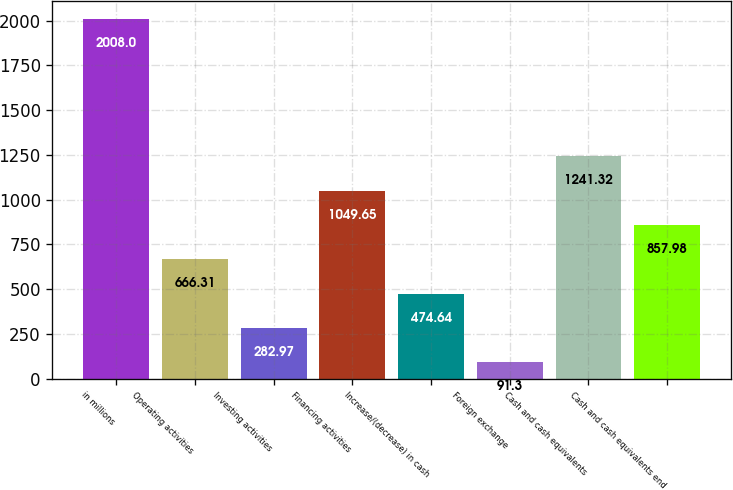Convert chart to OTSL. <chart><loc_0><loc_0><loc_500><loc_500><bar_chart><fcel>in millions<fcel>Operating activities<fcel>Investing activities<fcel>Financing activities<fcel>Increase/(decrease) in cash<fcel>Foreign exchange<fcel>Cash and cash equivalents<fcel>Cash and cash equivalents end<nl><fcel>2008<fcel>666.31<fcel>282.97<fcel>1049.65<fcel>474.64<fcel>91.3<fcel>1241.32<fcel>857.98<nl></chart> 